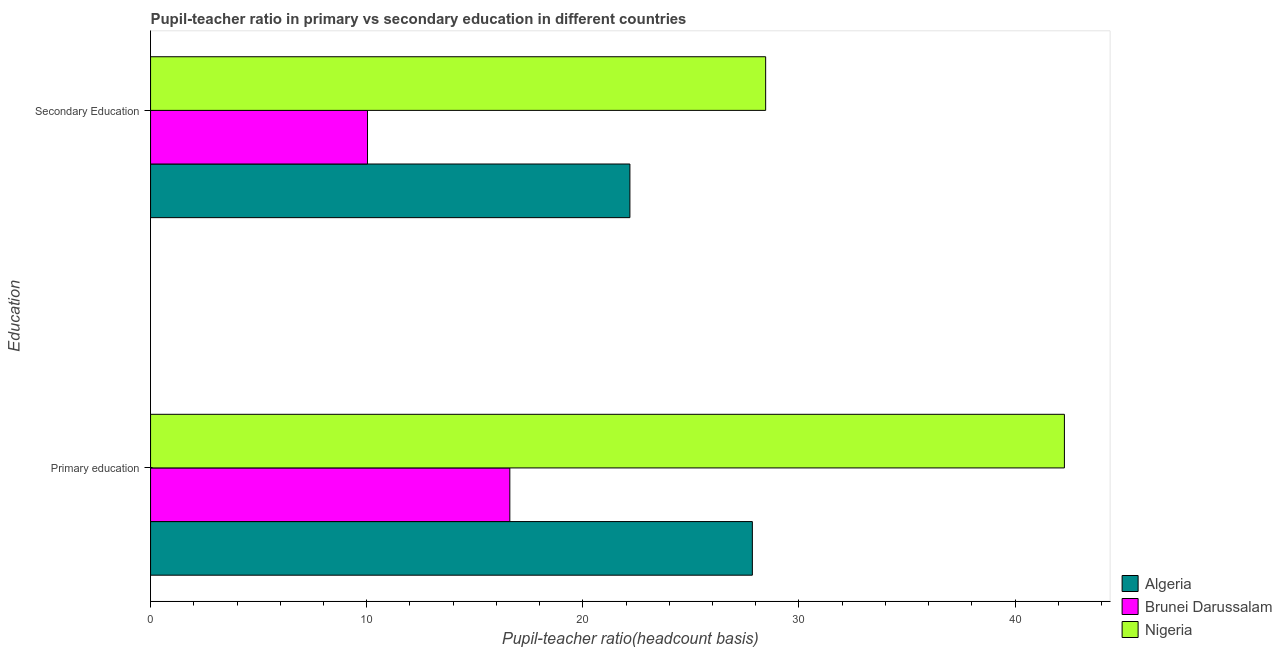How many different coloured bars are there?
Offer a terse response. 3. How many groups of bars are there?
Your answer should be compact. 2. Are the number of bars on each tick of the Y-axis equal?
Offer a terse response. Yes. How many bars are there on the 1st tick from the top?
Make the answer very short. 3. What is the pupil-teacher ratio in primary education in Nigeria?
Your response must be concise. 42.28. Across all countries, what is the maximum pupil-teacher ratio in primary education?
Ensure brevity in your answer.  42.28. Across all countries, what is the minimum pupil-teacher ratio in primary education?
Your response must be concise. 16.62. In which country was the pupil-teacher ratio in primary education maximum?
Keep it short and to the point. Nigeria. In which country was the pupil-teacher ratio in primary education minimum?
Provide a succinct answer. Brunei Darussalam. What is the total pupil teacher ratio on secondary education in the graph?
Offer a terse response. 60.67. What is the difference between the pupil teacher ratio on secondary education in Algeria and that in Nigeria?
Provide a short and direct response. -6.28. What is the difference between the pupil-teacher ratio in primary education in Nigeria and the pupil teacher ratio on secondary education in Algeria?
Provide a short and direct response. 20.1. What is the average pupil teacher ratio on secondary education per country?
Ensure brevity in your answer.  20.22. What is the difference between the pupil-teacher ratio in primary education and pupil teacher ratio on secondary education in Brunei Darussalam?
Offer a very short reply. 6.58. In how many countries, is the pupil-teacher ratio in primary education greater than 36 ?
Keep it short and to the point. 1. What is the ratio of the pupil teacher ratio on secondary education in Brunei Darussalam to that in Algeria?
Your answer should be compact. 0.45. In how many countries, is the pupil teacher ratio on secondary education greater than the average pupil teacher ratio on secondary education taken over all countries?
Provide a succinct answer. 2. What does the 2nd bar from the top in Secondary Education represents?
Make the answer very short. Brunei Darussalam. What does the 1st bar from the bottom in Secondary Education represents?
Make the answer very short. Algeria. How many bars are there?
Keep it short and to the point. 6. How many countries are there in the graph?
Offer a very short reply. 3. What is the difference between two consecutive major ticks on the X-axis?
Keep it short and to the point. 10. Are the values on the major ticks of X-axis written in scientific E-notation?
Provide a succinct answer. No. Does the graph contain any zero values?
Your response must be concise. No. Where does the legend appear in the graph?
Make the answer very short. Bottom right. How many legend labels are there?
Ensure brevity in your answer.  3. How are the legend labels stacked?
Keep it short and to the point. Vertical. What is the title of the graph?
Provide a short and direct response. Pupil-teacher ratio in primary vs secondary education in different countries. Does "Eritrea" appear as one of the legend labels in the graph?
Ensure brevity in your answer.  No. What is the label or title of the X-axis?
Your answer should be compact. Pupil-teacher ratio(headcount basis). What is the label or title of the Y-axis?
Your answer should be compact. Education. What is the Pupil-teacher ratio(headcount basis) of Algeria in Primary education?
Your answer should be compact. 27.84. What is the Pupil-teacher ratio(headcount basis) in Brunei Darussalam in Primary education?
Provide a succinct answer. 16.62. What is the Pupil-teacher ratio(headcount basis) of Nigeria in Primary education?
Your answer should be very brief. 42.28. What is the Pupil-teacher ratio(headcount basis) in Algeria in Secondary Education?
Your response must be concise. 22.18. What is the Pupil-teacher ratio(headcount basis) in Brunei Darussalam in Secondary Education?
Offer a terse response. 10.04. What is the Pupil-teacher ratio(headcount basis) in Nigeria in Secondary Education?
Provide a short and direct response. 28.46. Across all Education, what is the maximum Pupil-teacher ratio(headcount basis) in Algeria?
Your answer should be compact. 27.84. Across all Education, what is the maximum Pupil-teacher ratio(headcount basis) in Brunei Darussalam?
Ensure brevity in your answer.  16.62. Across all Education, what is the maximum Pupil-teacher ratio(headcount basis) in Nigeria?
Your answer should be compact. 42.28. Across all Education, what is the minimum Pupil-teacher ratio(headcount basis) in Algeria?
Offer a terse response. 22.18. Across all Education, what is the minimum Pupil-teacher ratio(headcount basis) in Brunei Darussalam?
Ensure brevity in your answer.  10.04. Across all Education, what is the minimum Pupil-teacher ratio(headcount basis) of Nigeria?
Offer a very short reply. 28.46. What is the total Pupil-teacher ratio(headcount basis) in Algeria in the graph?
Make the answer very short. 50.02. What is the total Pupil-teacher ratio(headcount basis) in Brunei Darussalam in the graph?
Offer a very short reply. 26.66. What is the total Pupil-teacher ratio(headcount basis) of Nigeria in the graph?
Give a very brief answer. 70.74. What is the difference between the Pupil-teacher ratio(headcount basis) of Algeria in Primary education and that in Secondary Education?
Provide a succinct answer. 5.67. What is the difference between the Pupil-teacher ratio(headcount basis) in Brunei Darussalam in Primary education and that in Secondary Education?
Your response must be concise. 6.58. What is the difference between the Pupil-teacher ratio(headcount basis) of Nigeria in Primary education and that in Secondary Education?
Provide a succinct answer. 13.82. What is the difference between the Pupil-teacher ratio(headcount basis) in Algeria in Primary education and the Pupil-teacher ratio(headcount basis) in Brunei Darussalam in Secondary Education?
Your response must be concise. 17.81. What is the difference between the Pupil-teacher ratio(headcount basis) in Algeria in Primary education and the Pupil-teacher ratio(headcount basis) in Nigeria in Secondary Education?
Make the answer very short. -0.62. What is the difference between the Pupil-teacher ratio(headcount basis) in Brunei Darussalam in Primary education and the Pupil-teacher ratio(headcount basis) in Nigeria in Secondary Education?
Give a very brief answer. -11.84. What is the average Pupil-teacher ratio(headcount basis) of Algeria per Education?
Make the answer very short. 25.01. What is the average Pupil-teacher ratio(headcount basis) in Brunei Darussalam per Education?
Your answer should be very brief. 13.33. What is the average Pupil-teacher ratio(headcount basis) of Nigeria per Education?
Your answer should be very brief. 35.37. What is the difference between the Pupil-teacher ratio(headcount basis) of Algeria and Pupil-teacher ratio(headcount basis) of Brunei Darussalam in Primary education?
Offer a terse response. 11.22. What is the difference between the Pupil-teacher ratio(headcount basis) in Algeria and Pupil-teacher ratio(headcount basis) in Nigeria in Primary education?
Your answer should be compact. -14.44. What is the difference between the Pupil-teacher ratio(headcount basis) of Brunei Darussalam and Pupil-teacher ratio(headcount basis) of Nigeria in Primary education?
Offer a very short reply. -25.66. What is the difference between the Pupil-teacher ratio(headcount basis) of Algeria and Pupil-teacher ratio(headcount basis) of Brunei Darussalam in Secondary Education?
Ensure brevity in your answer.  12.14. What is the difference between the Pupil-teacher ratio(headcount basis) of Algeria and Pupil-teacher ratio(headcount basis) of Nigeria in Secondary Education?
Your response must be concise. -6.28. What is the difference between the Pupil-teacher ratio(headcount basis) of Brunei Darussalam and Pupil-teacher ratio(headcount basis) of Nigeria in Secondary Education?
Provide a short and direct response. -18.42. What is the ratio of the Pupil-teacher ratio(headcount basis) of Algeria in Primary education to that in Secondary Education?
Your answer should be very brief. 1.26. What is the ratio of the Pupil-teacher ratio(headcount basis) of Brunei Darussalam in Primary education to that in Secondary Education?
Provide a short and direct response. 1.66. What is the ratio of the Pupil-teacher ratio(headcount basis) of Nigeria in Primary education to that in Secondary Education?
Keep it short and to the point. 1.49. What is the difference between the highest and the second highest Pupil-teacher ratio(headcount basis) of Algeria?
Your answer should be very brief. 5.67. What is the difference between the highest and the second highest Pupil-teacher ratio(headcount basis) of Brunei Darussalam?
Offer a very short reply. 6.58. What is the difference between the highest and the second highest Pupil-teacher ratio(headcount basis) in Nigeria?
Give a very brief answer. 13.82. What is the difference between the highest and the lowest Pupil-teacher ratio(headcount basis) of Algeria?
Ensure brevity in your answer.  5.67. What is the difference between the highest and the lowest Pupil-teacher ratio(headcount basis) in Brunei Darussalam?
Provide a short and direct response. 6.58. What is the difference between the highest and the lowest Pupil-teacher ratio(headcount basis) of Nigeria?
Your response must be concise. 13.82. 